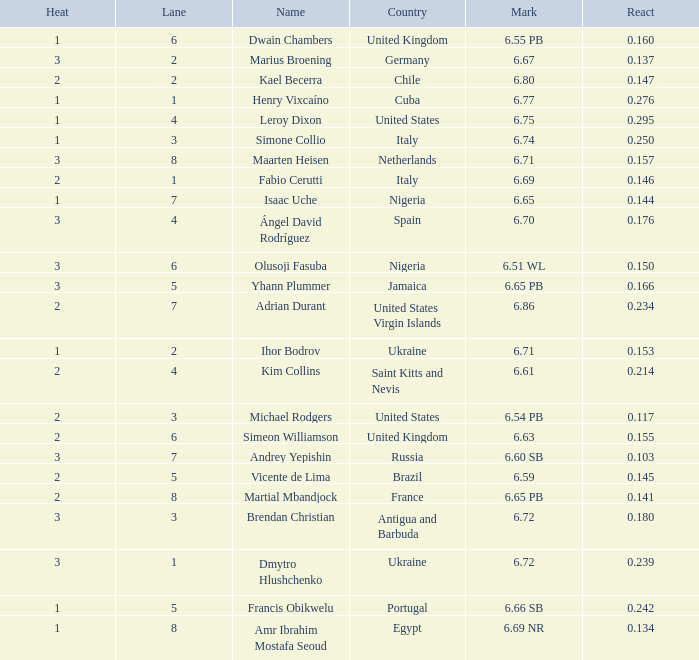What is Heat, when Mark is 6.69? 2.0. 